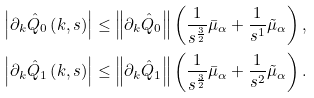Convert formula to latex. <formula><loc_0><loc_0><loc_500><loc_500>\left | \partial _ { k } \hat { Q } _ { 0 } \left ( k , s \right ) \right | & \leq \left \| \partial _ { k } \hat { Q } _ { 0 } \right \| \left ( \frac { 1 } { s ^ { \frac { 3 } { 2 } } } \bar { \mu } _ { \alpha } + \frac { 1 } { s ^ { 1 } } \tilde { \mu } _ { \alpha } \right ) , \\ \left | \partial _ { k } \hat { Q } _ { 1 } \left ( k , s \right ) \right | & \leq \left \| \partial _ { k } \hat { Q } _ { 1 } \right \| \left ( \frac { 1 } { s ^ { \frac { 3 } { 2 } } } \bar { \mu } _ { \alpha } + \frac { 1 } { s ^ { 2 } } \tilde { \mu } _ { \alpha } \right ) .</formula> 